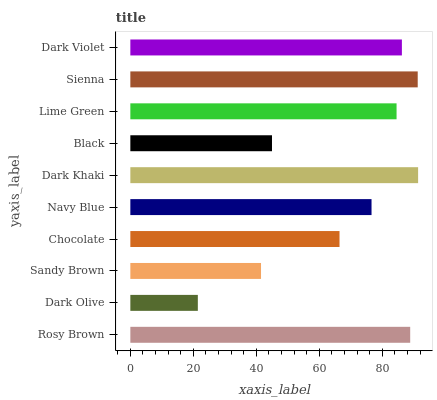Is Dark Olive the minimum?
Answer yes or no. Yes. Is Dark Khaki the maximum?
Answer yes or no. Yes. Is Sandy Brown the minimum?
Answer yes or no. No. Is Sandy Brown the maximum?
Answer yes or no. No. Is Sandy Brown greater than Dark Olive?
Answer yes or no. Yes. Is Dark Olive less than Sandy Brown?
Answer yes or no. Yes. Is Dark Olive greater than Sandy Brown?
Answer yes or no. No. Is Sandy Brown less than Dark Olive?
Answer yes or no. No. Is Lime Green the high median?
Answer yes or no. Yes. Is Navy Blue the low median?
Answer yes or no. Yes. Is Navy Blue the high median?
Answer yes or no. No. Is Lime Green the low median?
Answer yes or no. No. 